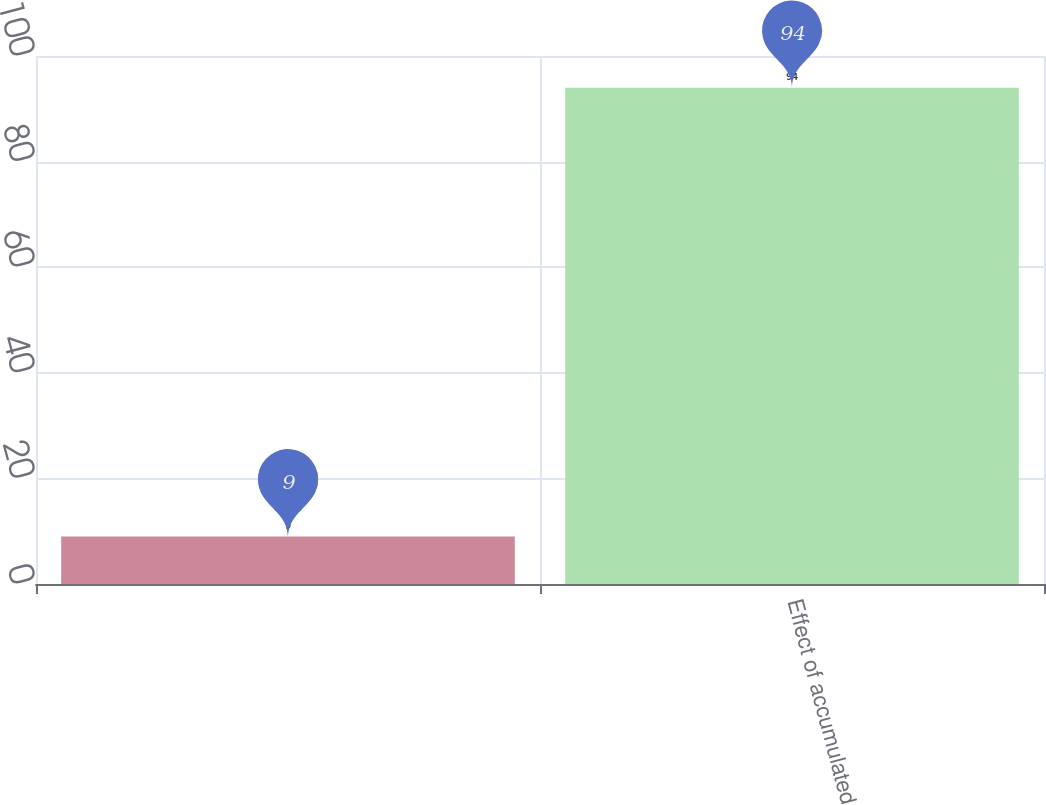Convert chart. <chart><loc_0><loc_0><loc_500><loc_500><bar_chart><ecel><fcel>Effect of accumulated<nl><fcel>9<fcel>94<nl></chart> 